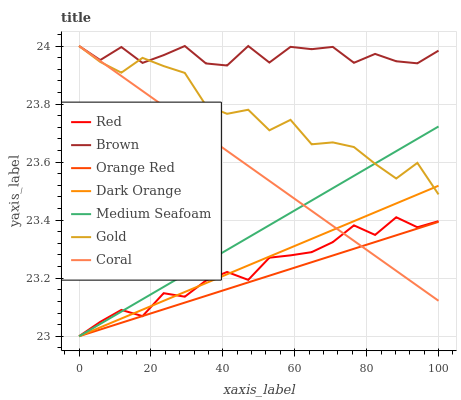Does Gold have the minimum area under the curve?
Answer yes or no. No. Does Gold have the maximum area under the curve?
Answer yes or no. No. Is Dark Orange the smoothest?
Answer yes or no. No. Is Dark Orange the roughest?
Answer yes or no. No. Does Gold have the lowest value?
Answer yes or no. No. Does Dark Orange have the highest value?
Answer yes or no. No. Is Orange Red less than Brown?
Answer yes or no. Yes. Is Brown greater than Orange Red?
Answer yes or no. Yes. Does Orange Red intersect Brown?
Answer yes or no. No. 